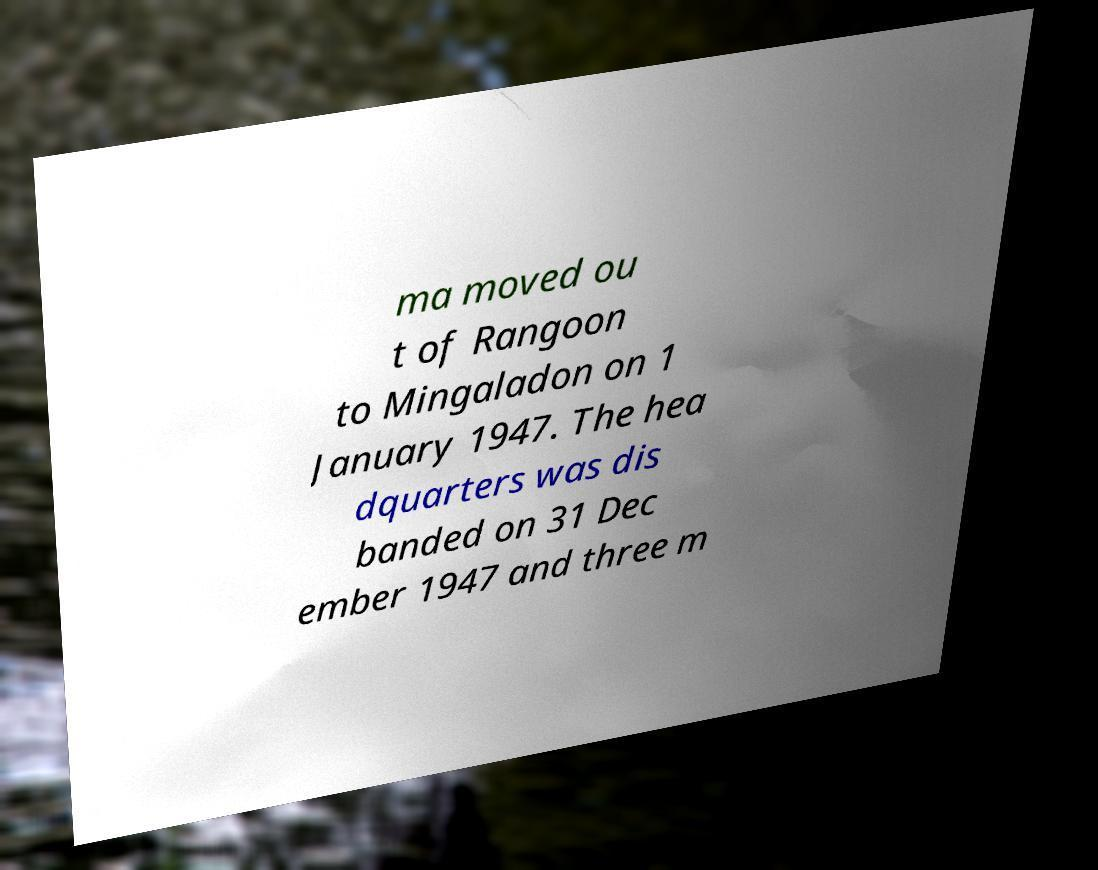Can you accurately transcribe the text from the provided image for me? ma moved ou t of Rangoon to Mingaladon on 1 January 1947. The hea dquarters was dis banded on 31 Dec ember 1947 and three m 